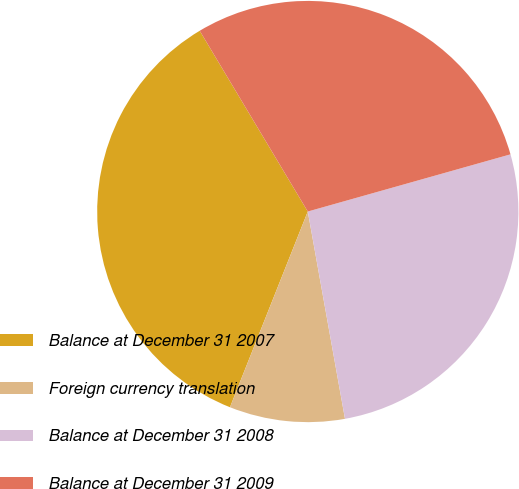Convert chart to OTSL. <chart><loc_0><loc_0><loc_500><loc_500><pie_chart><fcel>Balance at December 31 2007<fcel>Foreign currency translation<fcel>Balance at December 31 2008<fcel>Balance at December 31 2009<nl><fcel>35.4%<fcel>8.85%<fcel>26.55%<fcel>29.2%<nl></chart> 